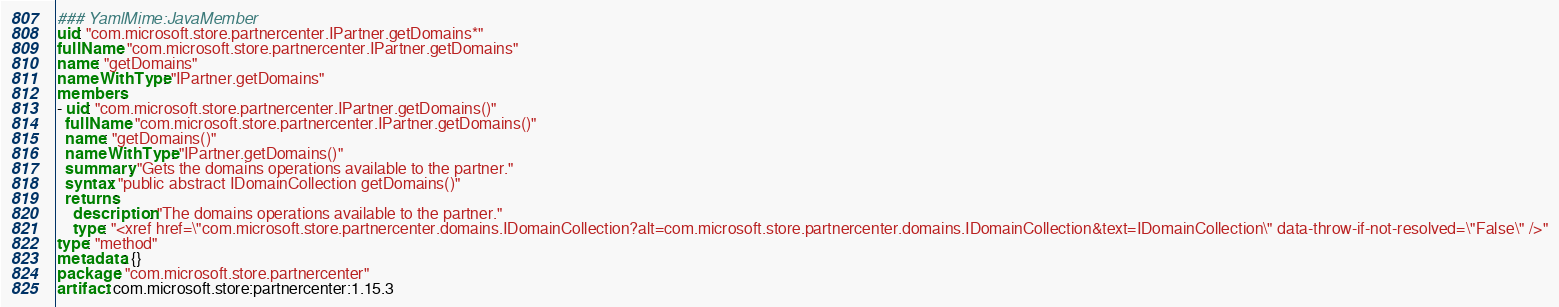Convert code to text. <code><loc_0><loc_0><loc_500><loc_500><_YAML_>### YamlMime:JavaMember
uid: "com.microsoft.store.partnercenter.IPartner.getDomains*"
fullName: "com.microsoft.store.partnercenter.IPartner.getDomains"
name: "getDomains"
nameWithType: "IPartner.getDomains"
members:
- uid: "com.microsoft.store.partnercenter.IPartner.getDomains()"
  fullName: "com.microsoft.store.partnercenter.IPartner.getDomains()"
  name: "getDomains()"
  nameWithType: "IPartner.getDomains()"
  summary: "Gets the domains operations available to the partner."
  syntax: "public abstract IDomainCollection getDomains()"
  returns:
    description: "The domains operations available to the partner."
    type: "<xref href=\"com.microsoft.store.partnercenter.domains.IDomainCollection?alt=com.microsoft.store.partnercenter.domains.IDomainCollection&text=IDomainCollection\" data-throw-if-not-resolved=\"False\" />"
type: "method"
metadata: {}
package: "com.microsoft.store.partnercenter"
artifact: com.microsoft.store:partnercenter:1.15.3
</code> 